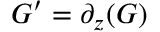Convert formula to latex. <formula><loc_0><loc_0><loc_500><loc_500>G ^ { \prime } = \partial _ { z } ( G )</formula> 